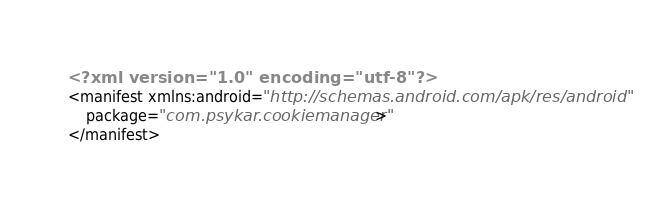<code> <loc_0><loc_0><loc_500><loc_500><_XML_><?xml version="1.0" encoding="utf-8"?>
<manifest xmlns:android="http://schemas.android.com/apk/res/android"
    package="com.psykar.cookiemanager" >
</manifest></code> 